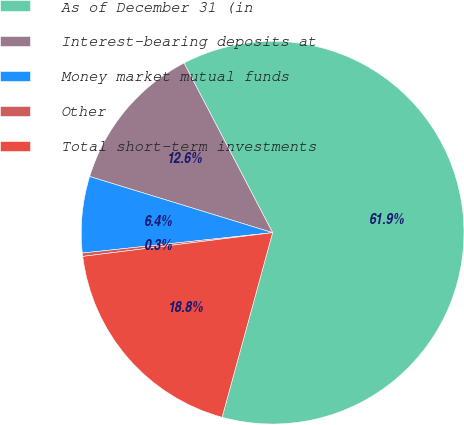Convert chart. <chart><loc_0><loc_0><loc_500><loc_500><pie_chart><fcel>As of December 31 (in<fcel>Interest-bearing deposits at<fcel>Money market mutual funds<fcel>Other<fcel>Total short-term investments<nl><fcel>61.91%<fcel>12.6%<fcel>6.44%<fcel>0.28%<fcel>18.77%<nl></chart> 